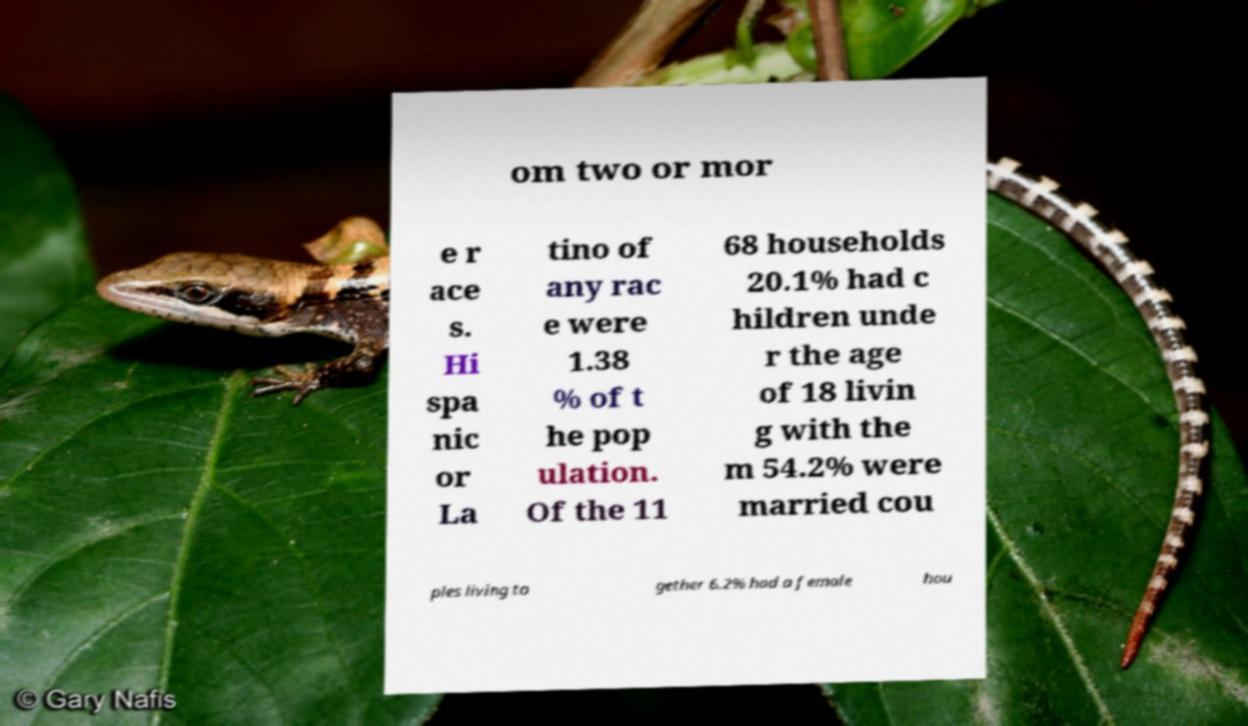Could you extract and type out the text from this image? om two or mor e r ace s. Hi spa nic or La tino of any rac e were 1.38 % of t he pop ulation. Of the 11 68 households 20.1% had c hildren unde r the age of 18 livin g with the m 54.2% were married cou ples living to gether 6.2% had a female hou 